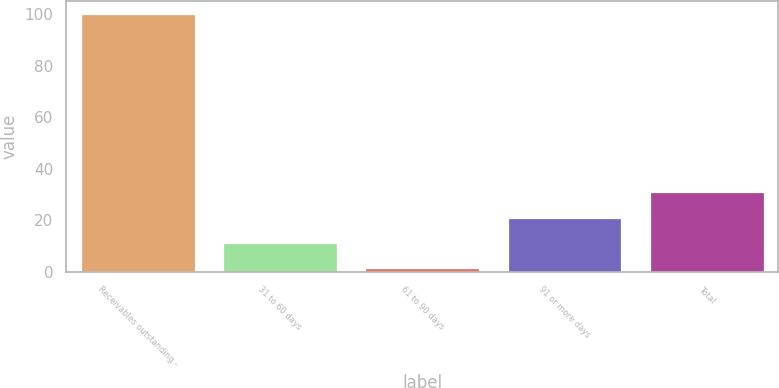<chart> <loc_0><loc_0><loc_500><loc_500><bar_chart><fcel>Receivables outstanding -<fcel>31 to 60 days<fcel>61 to 90 days<fcel>91 or more days<fcel>Total<nl><fcel>100<fcel>11.17<fcel>1.3<fcel>21.04<fcel>30.91<nl></chart> 